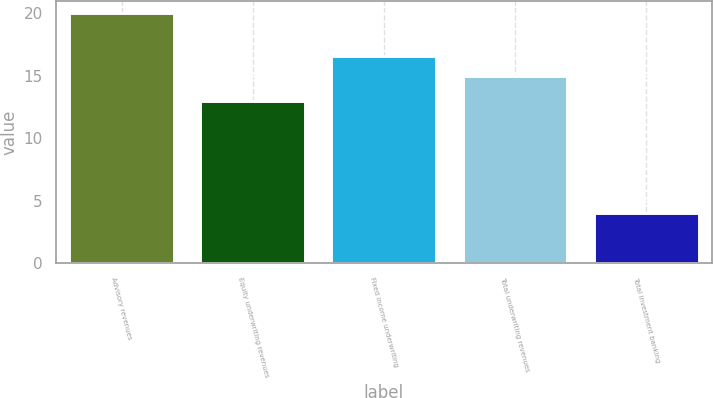Convert chart. <chart><loc_0><loc_0><loc_500><loc_500><bar_chart><fcel>Advisory revenues<fcel>Equity underwriting revenues<fcel>Fixed income underwriting<fcel>Total underwriting revenues<fcel>Total investment banking<nl><fcel>20<fcel>13<fcel>16.6<fcel>15<fcel>4<nl></chart> 